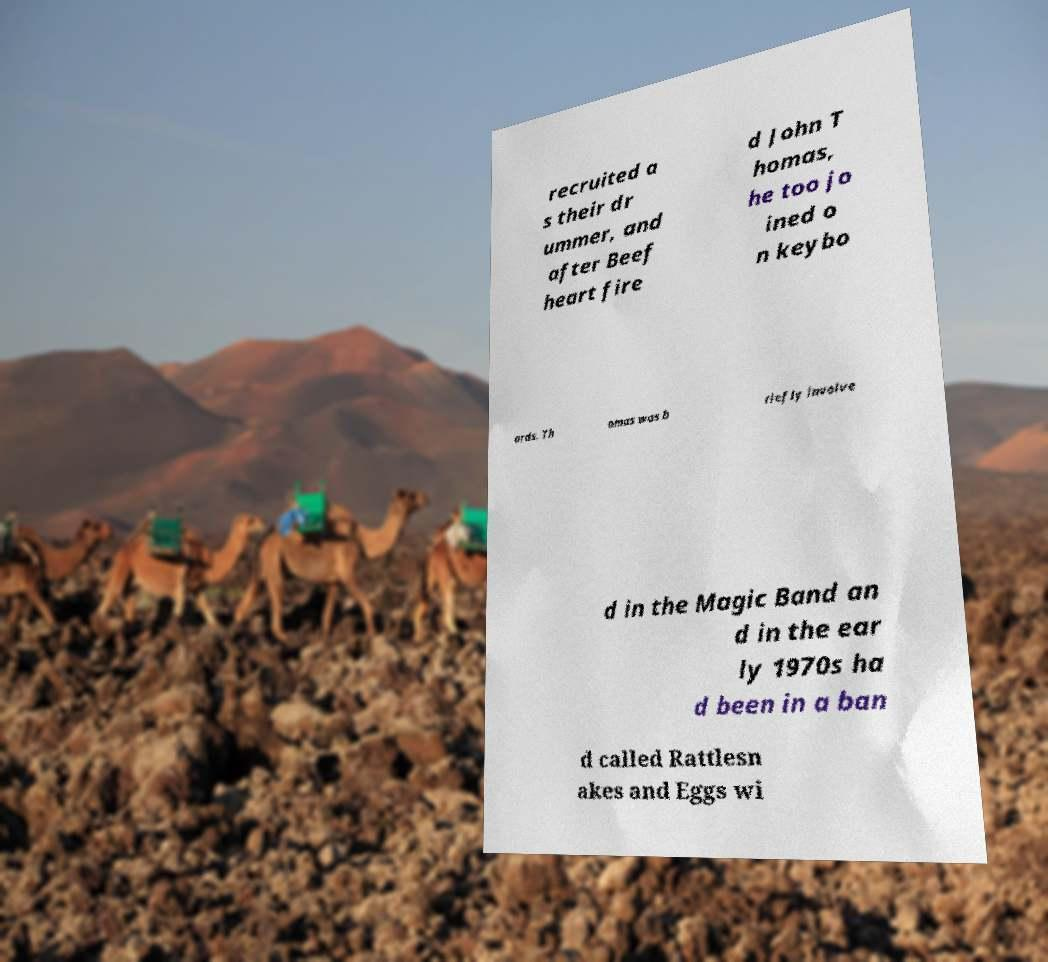Could you assist in decoding the text presented in this image and type it out clearly? recruited a s their dr ummer, and after Beef heart fire d John T homas, he too jo ined o n keybo ards. Th omas was b riefly involve d in the Magic Band an d in the ear ly 1970s ha d been in a ban d called Rattlesn akes and Eggs wi 